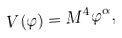<formula> <loc_0><loc_0><loc_500><loc_500>V ( \varphi ) = M ^ { 4 } \varphi ^ { \alpha } ,</formula> 